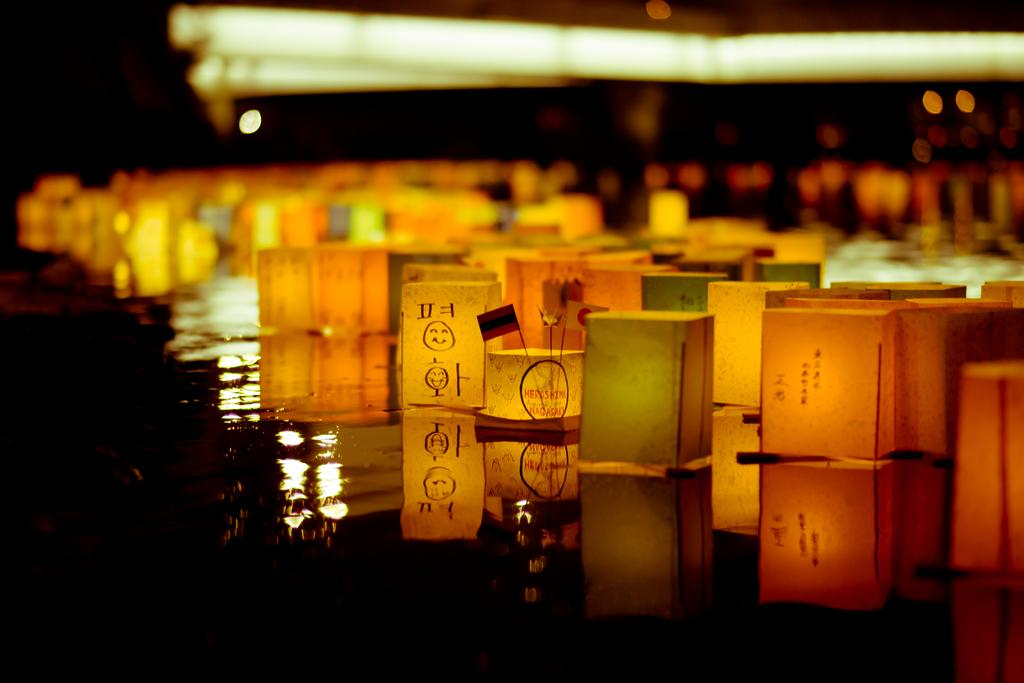What objects are floating on the water in the image? There are lanterns floating on the water in the image. What feature do the lanterns have? The lanterns have lights on the top. What type of lettuce is being served on the side in the image? There is no lettuce or any food present in the image; it features lanterns floating on the water with lights on top. 